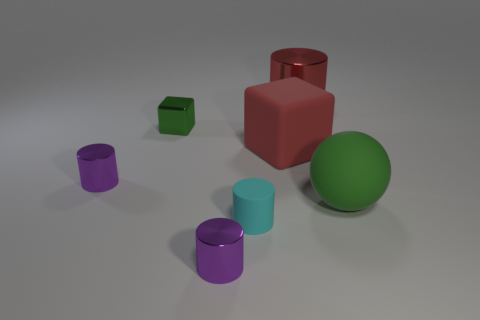Subtract all red cylinders. How many cylinders are left? 3 Subtract all cyan cylinders. How many cylinders are left? 3 Subtract all cylinders. How many objects are left? 3 Add 1 cyan cylinders. How many objects exist? 8 Subtract 1 cubes. How many cubes are left? 1 Subtract all matte cubes. Subtract all cyan cylinders. How many objects are left? 5 Add 1 tiny metal blocks. How many tiny metal blocks are left? 2 Add 2 large matte balls. How many large matte balls exist? 3 Subtract 0 blue blocks. How many objects are left? 7 Subtract all gray cylinders. Subtract all brown spheres. How many cylinders are left? 4 